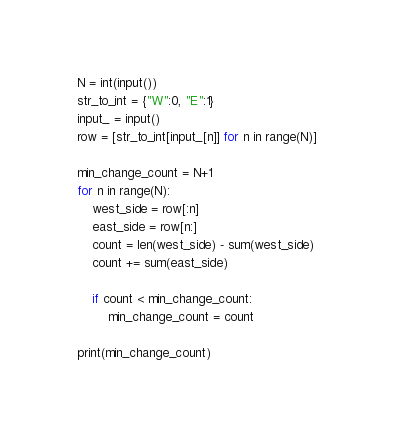<code> <loc_0><loc_0><loc_500><loc_500><_Python_>N = int(input())
str_to_int = {"W":0, "E":1}
input_ = input()
row = [str_to_int[input_[n]] for n in range(N)]

min_change_count = N+1
for n in range(N):
    west_side = row[:n]
    east_side = row[n:]
    count = len(west_side) - sum(west_side)
    count += sum(east_side)
    
    if count < min_change_count:
        min_change_count = count
        
print(min_change_count)</code> 